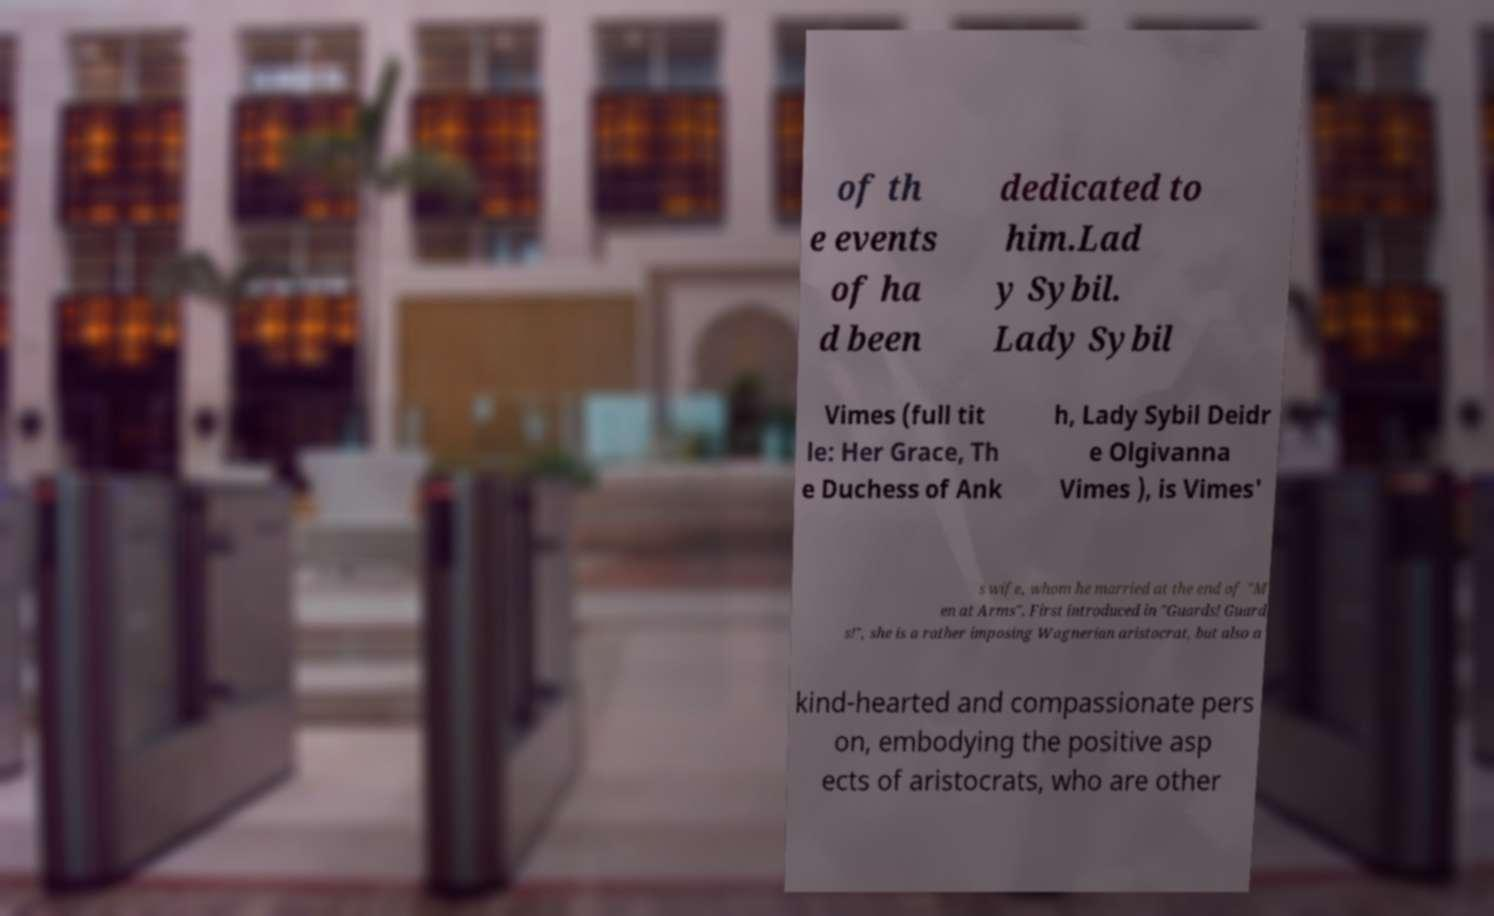Please read and relay the text visible in this image. What does it say? of th e events of ha d been dedicated to him.Lad y Sybil. Lady Sybil Vimes (full tit le: Her Grace, Th e Duchess of Ank h, Lady Sybil Deidr e Olgivanna Vimes ), is Vimes' s wife, whom he married at the end of "M en at Arms". First introduced in "Guards! Guard s!", she is a rather imposing Wagnerian aristocrat, but also a kind-hearted and compassionate pers on, embodying the positive asp ects of aristocrats, who are other 